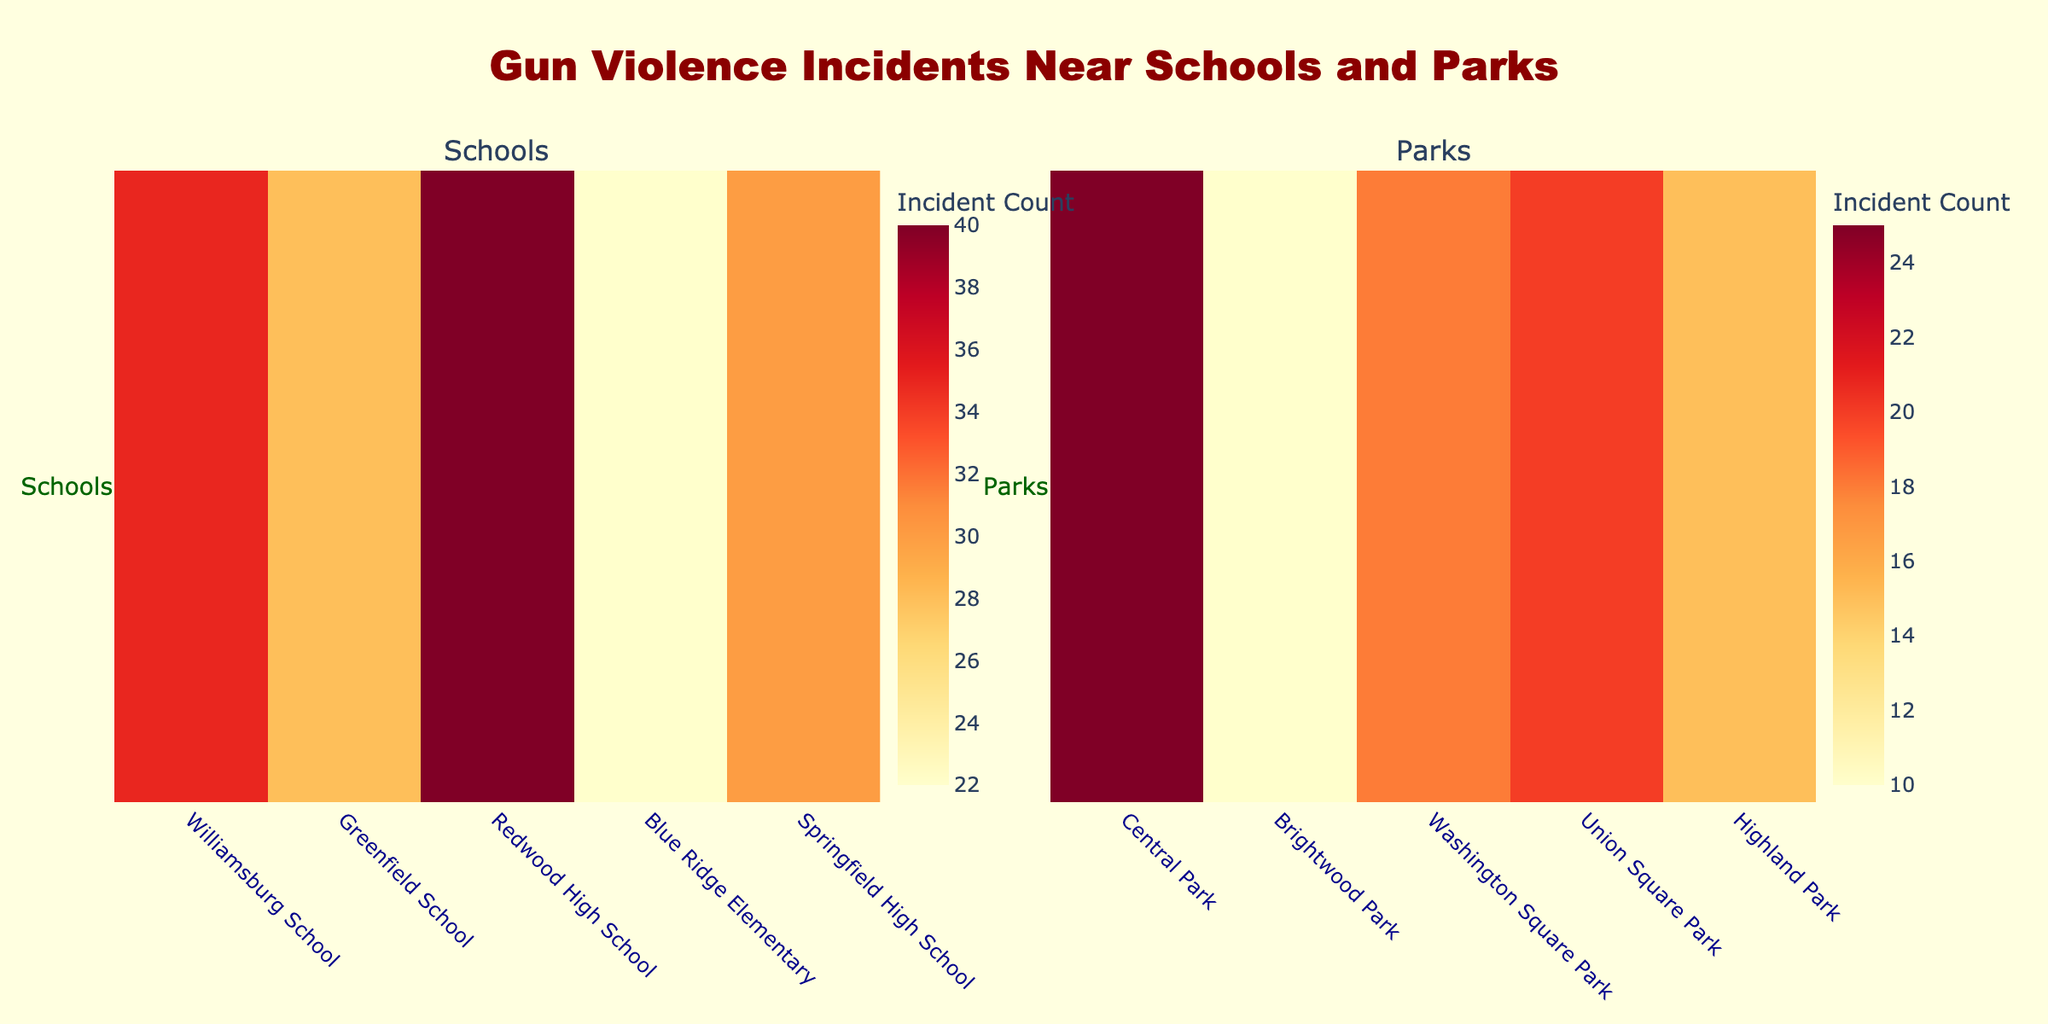What is the title of the figure? The title is located at the top center of the figure, formatted in large, red, bold text. It conveys the subject of the visual data.
Answer: Gun Violence Incidents Near Schools and Parks Which location has the highest incident count near schools? By examining the heatmap under the "Schools" section, you can identify the cell with the highest color intensity, which corresponds to the highest incident count.
Answer: Redwood High School What is the sum of incident counts near parks? Add the incident counts for all parks: Central Park (25), Brightwood Park (10), Washington Square Park (18), Union Square Park (20), and Highland Park (15). So, 25 + 10 + 18 + 20 + 15 = 88.
Answer: 88 Compare the highest incident count for schools to the highest for parks. Locate the highest values in both the "Schools" and "Parks" heatmaps. Redwood High School has an incident count of 40, while Central Park's count is 25.
Answer: 40 is greater than 25 Which location has the least incident count near schools? By examining the heatmap under the "Schools" section, you can identify the cell with the lowest color intensity, signifying the smallest incident count.
Answer: Blue Ridge Elementary How many locations are included in the "Parks" heatmap? Skim through the x-axis labels under the "Parks" section of the figure to count the number of unique locations.
Answer: 5 What is the average incident count near schools? Add up all incident counts for schools (35, 28, 40, 22, 30). The total is 155. Divide by the number of schools (5). So, 155 / 5 = 31.
Answer: 31 Which park has the second highest incident count? Sort the incident counts for parks and select the second highest value. Union Square Park has the highest (20), followed by Washington Square Park (18).
Answer: Washington Square Park Which school has an incident count of 30? Identify the location on the x-axis in the "Schools" section that has the color intensity corresponding to an incident count of 30.
Answer: Springfield High School What is the difference in incident counts between Central Park and Union Square Park? Subtract the incident count of Union Square Park from that of Central Park. So, 25 (Central Park) - 20 (Union Square Park) = 5.
Answer: 5 